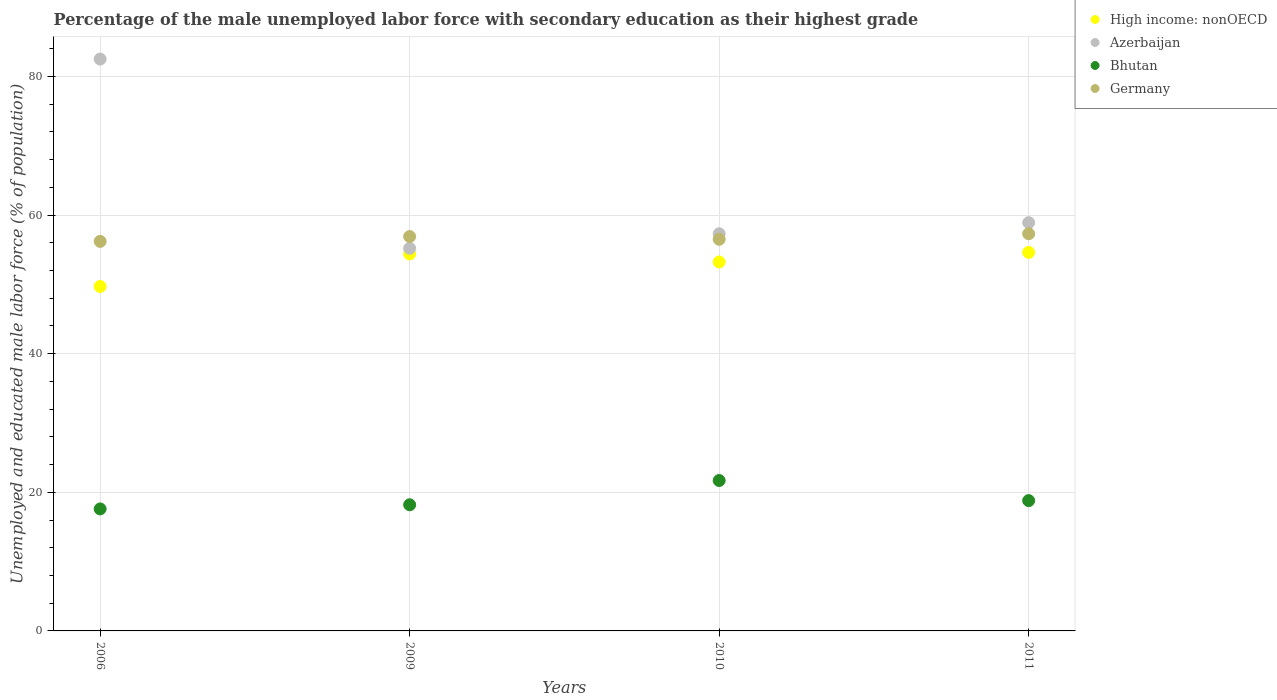How many different coloured dotlines are there?
Keep it short and to the point. 4. Is the number of dotlines equal to the number of legend labels?
Give a very brief answer. Yes. What is the percentage of the unemployed male labor force with secondary education in Germany in 2010?
Offer a very short reply. 56.5. Across all years, what is the maximum percentage of the unemployed male labor force with secondary education in Germany?
Give a very brief answer. 57.3. Across all years, what is the minimum percentage of the unemployed male labor force with secondary education in Azerbaijan?
Offer a very short reply. 55.2. In which year was the percentage of the unemployed male labor force with secondary education in Germany maximum?
Provide a succinct answer. 2011. What is the total percentage of the unemployed male labor force with secondary education in Azerbaijan in the graph?
Ensure brevity in your answer.  253.9. What is the difference between the percentage of the unemployed male labor force with secondary education in Bhutan in 2006 and that in 2009?
Provide a short and direct response. -0.6. What is the difference between the percentage of the unemployed male labor force with secondary education in High income: nonOECD in 2011 and the percentage of the unemployed male labor force with secondary education in Bhutan in 2010?
Keep it short and to the point. 32.91. What is the average percentage of the unemployed male labor force with secondary education in Azerbaijan per year?
Offer a very short reply. 63.48. In the year 2011, what is the difference between the percentage of the unemployed male labor force with secondary education in Germany and percentage of the unemployed male labor force with secondary education in High income: nonOECD?
Provide a short and direct response. 2.69. In how many years, is the percentage of the unemployed male labor force with secondary education in Germany greater than 80 %?
Give a very brief answer. 0. What is the ratio of the percentage of the unemployed male labor force with secondary education in Germany in 2009 to that in 2011?
Give a very brief answer. 0.99. Is the difference between the percentage of the unemployed male labor force with secondary education in Germany in 2009 and 2011 greater than the difference between the percentage of the unemployed male labor force with secondary education in High income: nonOECD in 2009 and 2011?
Offer a terse response. No. What is the difference between the highest and the second highest percentage of the unemployed male labor force with secondary education in Bhutan?
Provide a short and direct response. 2.9. What is the difference between the highest and the lowest percentage of the unemployed male labor force with secondary education in High income: nonOECD?
Ensure brevity in your answer.  4.92. Is the sum of the percentage of the unemployed male labor force with secondary education in Azerbaijan in 2006 and 2010 greater than the maximum percentage of the unemployed male labor force with secondary education in Bhutan across all years?
Your answer should be compact. Yes. Is it the case that in every year, the sum of the percentage of the unemployed male labor force with secondary education in High income: nonOECD and percentage of the unemployed male labor force with secondary education in Bhutan  is greater than the percentage of the unemployed male labor force with secondary education in Germany?
Provide a succinct answer. Yes. Is the percentage of the unemployed male labor force with secondary education in Germany strictly greater than the percentage of the unemployed male labor force with secondary education in Azerbaijan over the years?
Keep it short and to the point. No. How many years are there in the graph?
Ensure brevity in your answer.  4. What is the difference between two consecutive major ticks on the Y-axis?
Offer a very short reply. 20. Does the graph contain any zero values?
Keep it short and to the point. No. Does the graph contain grids?
Offer a very short reply. Yes. Where does the legend appear in the graph?
Provide a short and direct response. Top right. How many legend labels are there?
Keep it short and to the point. 4. How are the legend labels stacked?
Your answer should be very brief. Vertical. What is the title of the graph?
Keep it short and to the point. Percentage of the male unemployed labor force with secondary education as their highest grade. Does "Gabon" appear as one of the legend labels in the graph?
Keep it short and to the point. No. What is the label or title of the X-axis?
Keep it short and to the point. Years. What is the label or title of the Y-axis?
Your answer should be compact. Unemployed and educated male labor force (% of population). What is the Unemployed and educated male labor force (% of population) in High income: nonOECD in 2006?
Your answer should be compact. 49.69. What is the Unemployed and educated male labor force (% of population) in Azerbaijan in 2006?
Your answer should be compact. 82.5. What is the Unemployed and educated male labor force (% of population) in Bhutan in 2006?
Give a very brief answer. 17.6. What is the Unemployed and educated male labor force (% of population) in Germany in 2006?
Make the answer very short. 56.2. What is the Unemployed and educated male labor force (% of population) of High income: nonOECD in 2009?
Offer a terse response. 54.38. What is the Unemployed and educated male labor force (% of population) of Azerbaijan in 2009?
Give a very brief answer. 55.2. What is the Unemployed and educated male labor force (% of population) of Bhutan in 2009?
Offer a terse response. 18.2. What is the Unemployed and educated male labor force (% of population) of Germany in 2009?
Offer a terse response. 56.9. What is the Unemployed and educated male labor force (% of population) of High income: nonOECD in 2010?
Your answer should be compact. 53.23. What is the Unemployed and educated male labor force (% of population) of Azerbaijan in 2010?
Make the answer very short. 57.3. What is the Unemployed and educated male labor force (% of population) of Bhutan in 2010?
Provide a short and direct response. 21.7. What is the Unemployed and educated male labor force (% of population) of Germany in 2010?
Ensure brevity in your answer.  56.5. What is the Unemployed and educated male labor force (% of population) of High income: nonOECD in 2011?
Offer a terse response. 54.61. What is the Unemployed and educated male labor force (% of population) in Azerbaijan in 2011?
Offer a very short reply. 58.9. What is the Unemployed and educated male labor force (% of population) of Bhutan in 2011?
Offer a terse response. 18.8. What is the Unemployed and educated male labor force (% of population) of Germany in 2011?
Give a very brief answer. 57.3. Across all years, what is the maximum Unemployed and educated male labor force (% of population) of High income: nonOECD?
Your response must be concise. 54.61. Across all years, what is the maximum Unemployed and educated male labor force (% of population) in Azerbaijan?
Your response must be concise. 82.5. Across all years, what is the maximum Unemployed and educated male labor force (% of population) in Bhutan?
Provide a short and direct response. 21.7. Across all years, what is the maximum Unemployed and educated male labor force (% of population) in Germany?
Ensure brevity in your answer.  57.3. Across all years, what is the minimum Unemployed and educated male labor force (% of population) in High income: nonOECD?
Provide a short and direct response. 49.69. Across all years, what is the minimum Unemployed and educated male labor force (% of population) in Azerbaijan?
Give a very brief answer. 55.2. Across all years, what is the minimum Unemployed and educated male labor force (% of population) in Bhutan?
Provide a short and direct response. 17.6. Across all years, what is the minimum Unemployed and educated male labor force (% of population) in Germany?
Your response must be concise. 56.2. What is the total Unemployed and educated male labor force (% of population) in High income: nonOECD in the graph?
Offer a very short reply. 211.91. What is the total Unemployed and educated male labor force (% of population) of Azerbaijan in the graph?
Offer a terse response. 253.9. What is the total Unemployed and educated male labor force (% of population) in Bhutan in the graph?
Provide a succinct answer. 76.3. What is the total Unemployed and educated male labor force (% of population) of Germany in the graph?
Ensure brevity in your answer.  226.9. What is the difference between the Unemployed and educated male labor force (% of population) in High income: nonOECD in 2006 and that in 2009?
Provide a short and direct response. -4.69. What is the difference between the Unemployed and educated male labor force (% of population) in Azerbaijan in 2006 and that in 2009?
Make the answer very short. 27.3. What is the difference between the Unemployed and educated male labor force (% of population) of Bhutan in 2006 and that in 2009?
Your answer should be very brief. -0.6. What is the difference between the Unemployed and educated male labor force (% of population) in Germany in 2006 and that in 2009?
Your answer should be very brief. -0.7. What is the difference between the Unemployed and educated male labor force (% of population) of High income: nonOECD in 2006 and that in 2010?
Your answer should be compact. -3.53. What is the difference between the Unemployed and educated male labor force (% of population) of Azerbaijan in 2006 and that in 2010?
Ensure brevity in your answer.  25.2. What is the difference between the Unemployed and educated male labor force (% of population) of Germany in 2006 and that in 2010?
Provide a short and direct response. -0.3. What is the difference between the Unemployed and educated male labor force (% of population) in High income: nonOECD in 2006 and that in 2011?
Provide a succinct answer. -4.92. What is the difference between the Unemployed and educated male labor force (% of population) in Azerbaijan in 2006 and that in 2011?
Your response must be concise. 23.6. What is the difference between the Unemployed and educated male labor force (% of population) in Germany in 2006 and that in 2011?
Give a very brief answer. -1.1. What is the difference between the Unemployed and educated male labor force (% of population) of High income: nonOECD in 2009 and that in 2010?
Keep it short and to the point. 1.16. What is the difference between the Unemployed and educated male labor force (% of population) of Germany in 2009 and that in 2010?
Provide a short and direct response. 0.4. What is the difference between the Unemployed and educated male labor force (% of population) in High income: nonOECD in 2009 and that in 2011?
Your response must be concise. -0.23. What is the difference between the Unemployed and educated male labor force (% of population) of Azerbaijan in 2009 and that in 2011?
Offer a terse response. -3.7. What is the difference between the Unemployed and educated male labor force (% of population) of Bhutan in 2009 and that in 2011?
Offer a very short reply. -0.6. What is the difference between the Unemployed and educated male labor force (% of population) in High income: nonOECD in 2010 and that in 2011?
Make the answer very short. -1.38. What is the difference between the Unemployed and educated male labor force (% of population) of Germany in 2010 and that in 2011?
Give a very brief answer. -0.8. What is the difference between the Unemployed and educated male labor force (% of population) of High income: nonOECD in 2006 and the Unemployed and educated male labor force (% of population) of Azerbaijan in 2009?
Offer a very short reply. -5.51. What is the difference between the Unemployed and educated male labor force (% of population) of High income: nonOECD in 2006 and the Unemployed and educated male labor force (% of population) of Bhutan in 2009?
Ensure brevity in your answer.  31.49. What is the difference between the Unemployed and educated male labor force (% of population) of High income: nonOECD in 2006 and the Unemployed and educated male labor force (% of population) of Germany in 2009?
Your answer should be very brief. -7.21. What is the difference between the Unemployed and educated male labor force (% of population) in Azerbaijan in 2006 and the Unemployed and educated male labor force (% of population) in Bhutan in 2009?
Give a very brief answer. 64.3. What is the difference between the Unemployed and educated male labor force (% of population) in Azerbaijan in 2006 and the Unemployed and educated male labor force (% of population) in Germany in 2009?
Your response must be concise. 25.6. What is the difference between the Unemployed and educated male labor force (% of population) in Bhutan in 2006 and the Unemployed and educated male labor force (% of population) in Germany in 2009?
Provide a short and direct response. -39.3. What is the difference between the Unemployed and educated male labor force (% of population) in High income: nonOECD in 2006 and the Unemployed and educated male labor force (% of population) in Azerbaijan in 2010?
Provide a short and direct response. -7.61. What is the difference between the Unemployed and educated male labor force (% of population) in High income: nonOECD in 2006 and the Unemployed and educated male labor force (% of population) in Bhutan in 2010?
Provide a short and direct response. 27.99. What is the difference between the Unemployed and educated male labor force (% of population) in High income: nonOECD in 2006 and the Unemployed and educated male labor force (% of population) in Germany in 2010?
Offer a terse response. -6.81. What is the difference between the Unemployed and educated male labor force (% of population) in Azerbaijan in 2006 and the Unemployed and educated male labor force (% of population) in Bhutan in 2010?
Provide a succinct answer. 60.8. What is the difference between the Unemployed and educated male labor force (% of population) in Bhutan in 2006 and the Unemployed and educated male labor force (% of population) in Germany in 2010?
Provide a succinct answer. -38.9. What is the difference between the Unemployed and educated male labor force (% of population) in High income: nonOECD in 2006 and the Unemployed and educated male labor force (% of population) in Azerbaijan in 2011?
Keep it short and to the point. -9.21. What is the difference between the Unemployed and educated male labor force (% of population) in High income: nonOECD in 2006 and the Unemployed and educated male labor force (% of population) in Bhutan in 2011?
Your response must be concise. 30.89. What is the difference between the Unemployed and educated male labor force (% of population) in High income: nonOECD in 2006 and the Unemployed and educated male labor force (% of population) in Germany in 2011?
Offer a terse response. -7.61. What is the difference between the Unemployed and educated male labor force (% of population) in Azerbaijan in 2006 and the Unemployed and educated male labor force (% of population) in Bhutan in 2011?
Give a very brief answer. 63.7. What is the difference between the Unemployed and educated male labor force (% of population) in Azerbaijan in 2006 and the Unemployed and educated male labor force (% of population) in Germany in 2011?
Your answer should be compact. 25.2. What is the difference between the Unemployed and educated male labor force (% of population) of Bhutan in 2006 and the Unemployed and educated male labor force (% of population) of Germany in 2011?
Provide a succinct answer. -39.7. What is the difference between the Unemployed and educated male labor force (% of population) in High income: nonOECD in 2009 and the Unemployed and educated male labor force (% of population) in Azerbaijan in 2010?
Offer a very short reply. -2.92. What is the difference between the Unemployed and educated male labor force (% of population) in High income: nonOECD in 2009 and the Unemployed and educated male labor force (% of population) in Bhutan in 2010?
Your answer should be very brief. 32.68. What is the difference between the Unemployed and educated male labor force (% of population) of High income: nonOECD in 2009 and the Unemployed and educated male labor force (% of population) of Germany in 2010?
Your response must be concise. -2.12. What is the difference between the Unemployed and educated male labor force (% of population) in Azerbaijan in 2009 and the Unemployed and educated male labor force (% of population) in Bhutan in 2010?
Give a very brief answer. 33.5. What is the difference between the Unemployed and educated male labor force (% of population) of Azerbaijan in 2009 and the Unemployed and educated male labor force (% of population) of Germany in 2010?
Your answer should be very brief. -1.3. What is the difference between the Unemployed and educated male labor force (% of population) in Bhutan in 2009 and the Unemployed and educated male labor force (% of population) in Germany in 2010?
Make the answer very short. -38.3. What is the difference between the Unemployed and educated male labor force (% of population) of High income: nonOECD in 2009 and the Unemployed and educated male labor force (% of population) of Azerbaijan in 2011?
Make the answer very short. -4.52. What is the difference between the Unemployed and educated male labor force (% of population) in High income: nonOECD in 2009 and the Unemployed and educated male labor force (% of population) in Bhutan in 2011?
Keep it short and to the point. 35.58. What is the difference between the Unemployed and educated male labor force (% of population) of High income: nonOECD in 2009 and the Unemployed and educated male labor force (% of population) of Germany in 2011?
Your answer should be compact. -2.92. What is the difference between the Unemployed and educated male labor force (% of population) of Azerbaijan in 2009 and the Unemployed and educated male labor force (% of population) of Bhutan in 2011?
Provide a succinct answer. 36.4. What is the difference between the Unemployed and educated male labor force (% of population) of Bhutan in 2009 and the Unemployed and educated male labor force (% of population) of Germany in 2011?
Offer a terse response. -39.1. What is the difference between the Unemployed and educated male labor force (% of population) in High income: nonOECD in 2010 and the Unemployed and educated male labor force (% of population) in Azerbaijan in 2011?
Your response must be concise. -5.67. What is the difference between the Unemployed and educated male labor force (% of population) of High income: nonOECD in 2010 and the Unemployed and educated male labor force (% of population) of Bhutan in 2011?
Offer a terse response. 34.43. What is the difference between the Unemployed and educated male labor force (% of population) of High income: nonOECD in 2010 and the Unemployed and educated male labor force (% of population) of Germany in 2011?
Your answer should be compact. -4.07. What is the difference between the Unemployed and educated male labor force (% of population) of Azerbaijan in 2010 and the Unemployed and educated male labor force (% of population) of Bhutan in 2011?
Your answer should be very brief. 38.5. What is the difference between the Unemployed and educated male labor force (% of population) in Bhutan in 2010 and the Unemployed and educated male labor force (% of population) in Germany in 2011?
Offer a terse response. -35.6. What is the average Unemployed and educated male labor force (% of population) in High income: nonOECD per year?
Ensure brevity in your answer.  52.98. What is the average Unemployed and educated male labor force (% of population) in Azerbaijan per year?
Keep it short and to the point. 63.48. What is the average Unemployed and educated male labor force (% of population) in Bhutan per year?
Make the answer very short. 19.07. What is the average Unemployed and educated male labor force (% of population) in Germany per year?
Give a very brief answer. 56.73. In the year 2006, what is the difference between the Unemployed and educated male labor force (% of population) in High income: nonOECD and Unemployed and educated male labor force (% of population) in Azerbaijan?
Offer a terse response. -32.81. In the year 2006, what is the difference between the Unemployed and educated male labor force (% of population) of High income: nonOECD and Unemployed and educated male labor force (% of population) of Bhutan?
Provide a succinct answer. 32.09. In the year 2006, what is the difference between the Unemployed and educated male labor force (% of population) in High income: nonOECD and Unemployed and educated male labor force (% of population) in Germany?
Keep it short and to the point. -6.51. In the year 2006, what is the difference between the Unemployed and educated male labor force (% of population) in Azerbaijan and Unemployed and educated male labor force (% of population) in Bhutan?
Provide a succinct answer. 64.9. In the year 2006, what is the difference between the Unemployed and educated male labor force (% of population) in Azerbaijan and Unemployed and educated male labor force (% of population) in Germany?
Ensure brevity in your answer.  26.3. In the year 2006, what is the difference between the Unemployed and educated male labor force (% of population) in Bhutan and Unemployed and educated male labor force (% of population) in Germany?
Offer a very short reply. -38.6. In the year 2009, what is the difference between the Unemployed and educated male labor force (% of population) in High income: nonOECD and Unemployed and educated male labor force (% of population) in Azerbaijan?
Your answer should be compact. -0.82. In the year 2009, what is the difference between the Unemployed and educated male labor force (% of population) in High income: nonOECD and Unemployed and educated male labor force (% of population) in Bhutan?
Keep it short and to the point. 36.18. In the year 2009, what is the difference between the Unemployed and educated male labor force (% of population) of High income: nonOECD and Unemployed and educated male labor force (% of population) of Germany?
Your response must be concise. -2.52. In the year 2009, what is the difference between the Unemployed and educated male labor force (% of population) of Azerbaijan and Unemployed and educated male labor force (% of population) of Bhutan?
Offer a very short reply. 37. In the year 2009, what is the difference between the Unemployed and educated male labor force (% of population) of Bhutan and Unemployed and educated male labor force (% of population) of Germany?
Your answer should be compact. -38.7. In the year 2010, what is the difference between the Unemployed and educated male labor force (% of population) in High income: nonOECD and Unemployed and educated male labor force (% of population) in Azerbaijan?
Offer a very short reply. -4.07. In the year 2010, what is the difference between the Unemployed and educated male labor force (% of population) in High income: nonOECD and Unemployed and educated male labor force (% of population) in Bhutan?
Keep it short and to the point. 31.53. In the year 2010, what is the difference between the Unemployed and educated male labor force (% of population) of High income: nonOECD and Unemployed and educated male labor force (% of population) of Germany?
Give a very brief answer. -3.27. In the year 2010, what is the difference between the Unemployed and educated male labor force (% of population) in Azerbaijan and Unemployed and educated male labor force (% of population) in Bhutan?
Give a very brief answer. 35.6. In the year 2010, what is the difference between the Unemployed and educated male labor force (% of population) in Azerbaijan and Unemployed and educated male labor force (% of population) in Germany?
Give a very brief answer. 0.8. In the year 2010, what is the difference between the Unemployed and educated male labor force (% of population) in Bhutan and Unemployed and educated male labor force (% of population) in Germany?
Provide a short and direct response. -34.8. In the year 2011, what is the difference between the Unemployed and educated male labor force (% of population) in High income: nonOECD and Unemployed and educated male labor force (% of population) in Azerbaijan?
Keep it short and to the point. -4.29. In the year 2011, what is the difference between the Unemployed and educated male labor force (% of population) in High income: nonOECD and Unemployed and educated male labor force (% of population) in Bhutan?
Your response must be concise. 35.81. In the year 2011, what is the difference between the Unemployed and educated male labor force (% of population) in High income: nonOECD and Unemployed and educated male labor force (% of population) in Germany?
Offer a terse response. -2.69. In the year 2011, what is the difference between the Unemployed and educated male labor force (% of population) of Azerbaijan and Unemployed and educated male labor force (% of population) of Bhutan?
Make the answer very short. 40.1. In the year 2011, what is the difference between the Unemployed and educated male labor force (% of population) in Azerbaijan and Unemployed and educated male labor force (% of population) in Germany?
Ensure brevity in your answer.  1.6. In the year 2011, what is the difference between the Unemployed and educated male labor force (% of population) of Bhutan and Unemployed and educated male labor force (% of population) of Germany?
Your answer should be very brief. -38.5. What is the ratio of the Unemployed and educated male labor force (% of population) in High income: nonOECD in 2006 to that in 2009?
Offer a very short reply. 0.91. What is the ratio of the Unemployed and educated male labor force (% of population) in Azerbaijan in 2006 to that in 2009?
Keep it short and to the point. 1.49. What is the ratio of the Unemployed and educated male labor force (% of population) in Bhutan in 2006 to that in 2009?
Your answer should be very brief. 0.97. What is the ratio of the Unemployed and educated male labor force (% of population) in High income: nonOECD in 2006 to that in 2010?
Provide a short and direct response. 0.93. What is the ratio of the Unemployed and educated male labor force (% of population) of Azerbaijan in 2006 to that in 2010?
Make the answer very short. 1.44. What is the ratio of the Unemployed and educated male labor force (% of population) of Bhutan in 2006 to that in 2010?
Give a very brief answer. 0.81. What is the ratio of the Unemployed and educated male labor force (% of population) in High income: nonOECD in 2006 to that in 2011?
Offer a very short reply. 0.91. What is the ratio of the Unemployed and educated male labor force (% of population) of Azerbaijan in 2006 to that in 2011?
Provide a succinct answer. 1.4. What is the ratio of the Unemployed and educated male labor force (% of population) in Bhutan in 2006 to that in 2011?
Make the answer very short. 0.94. What is the ratio of the Unemployed and educated male labor force (% of population) in Germany in 2006 to that in 2011?
Ensure brevity in your answer.  0.98. What is the ratio of the Unemployed and educated male labor force (% of population) of High income: nonOECD in 2009 to that in 2010?
Provide a short and direct response. 1.02. What is the ratio of the Unemployed and educated male labor force (% of population) in Azerbaijan in 2009 to that in 2010?
Your answer should be very brief. 0.96. What is the ratio of the Unemployed and educated male labor force (% of population) in Bhutan in 2009 to that in 2010?
Your answer should be very brief. 0.84. What is the ratio of the Unemployed and educated male labor force (% of population) in Germany in 2009 to that in 2010?
Keep it short and to the point. 1.01. What is the ratio of the Unemployed and educated male labor force (% of population) of Azerbaijan in 2009 to that in 2011?
Your answer should be very brief. 0.94. What is the ratio of the Unemployed and educated male labor force (% of population) of Bhutan in 2009 to that in 2011?
Keep it short and to the point. 0.97. What is the ratio of the Unemployed and educated male labor force (% of population) in High income: nonOECD in 2010 to that in 2011?
Give a very brief answer. 0.97. What is the ratio of the Unemployed and educated male labor force (% of population) of Azerbaijan in 2010 to that in 2011?
Your answer should be very brief. 0.97. What is the ratio of the Unemployed and educated male labor force (% of population) of Bhutan in 2010 to that in 2011?
Your answer should be compact. 1.15. What is the difference between the highest and the second highest Unemployed and educated male labor force (% of population) of High income: nonOECD?
Make the answer very short. 0.23. What is the difference between the highest and the second highest Unemployed and educated male labor force (% of population) in Azerbaijan?
Ensure brevity in your answer.  23.6. What is the difference between the highest and the second highest Unemployed and educated male labor force (% of population) of Bhutan?
Offer a very short reply. 2.9. What is the difference between the highest and the second highest Unemployed and educated male labor force (% of population) of Germany?
Your answer should be compact. 0.4. What is the difference between the highest and the lowest Unemployed and educated male labor force (% of population) in High income: nonOECD?
Make the answer very short. 4.92. What is the difference between the highest and the lowest Unemployed and educated male labor force (% of population) in Azerbaijan?
Your response must be concise. 27.3. 